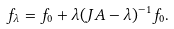Convert formula to latex. <formula><loc_0><loc_0><loc_500><loc_500>f _ { \lambda } = f _ { 0 } + \lambda ( J A - \lambda ) ^ { - 1 } f _ { 0 } .</formula> 